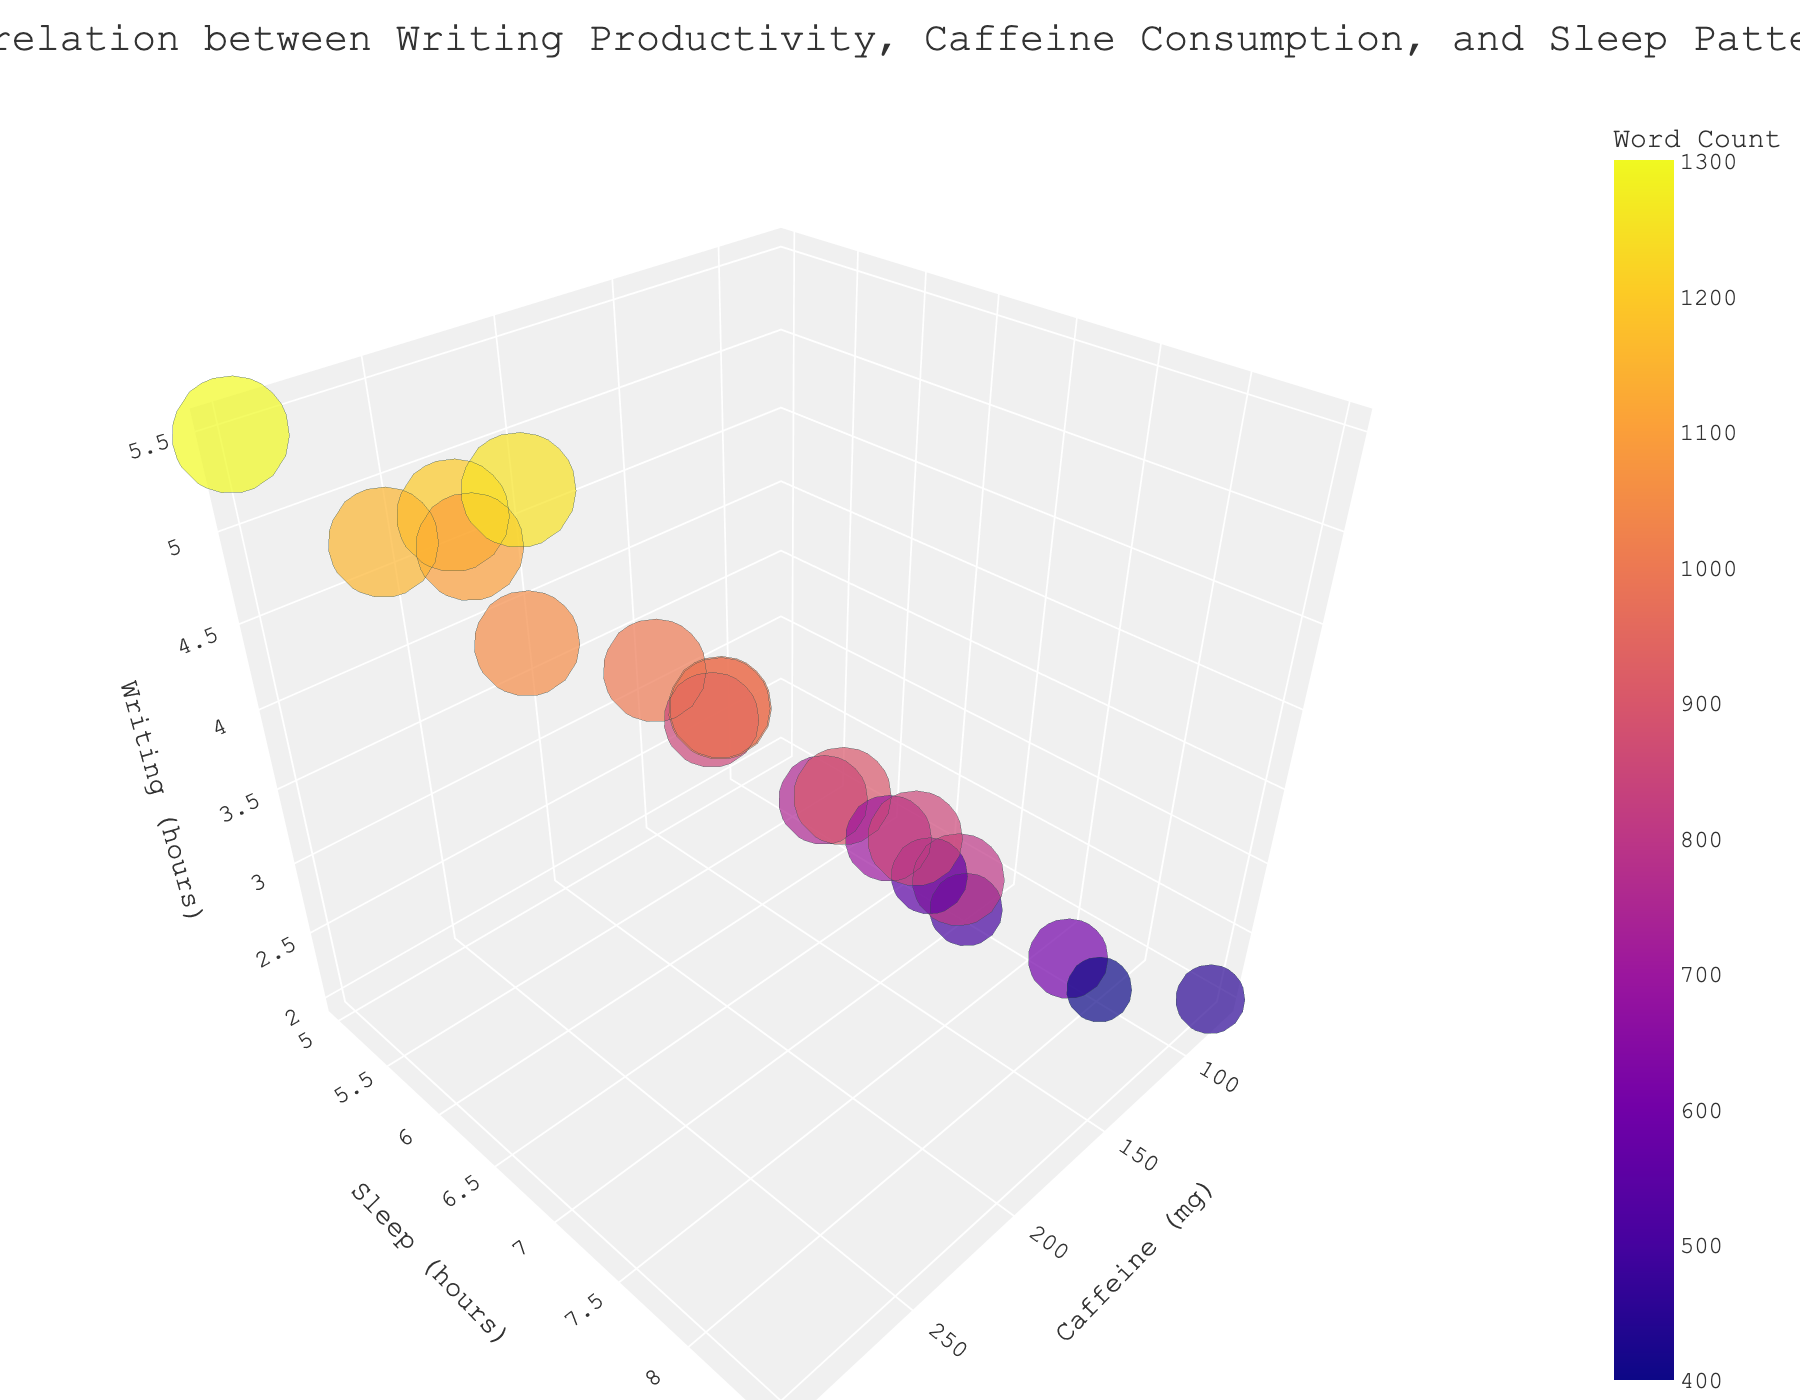What does the title of the chart indicate? The title "Correlation between Writing Productivity, Caffeine Consumption, and Sleep Patterns" suggests that the chart explores how writing hours (an indicator of productivity), caffeine intake, and sleep hours are related for aspiring authors.
Answer: It shows the relationship between writing hours, caffeine intake, and sleep What do the axes represent in the figure? The x-axis represents caffeine consumption in milligrams (Caffeine (mg)), the y-axis represents sleep duration in hours (Sleep (hours)), and the z-axis represents writing hours (Writing (hours)).
Answer: Caffeine intake, sleep duration, writing hours How many data points are shown in the figure? There are 20 data points visible on the chart, corresponding to 20 different observations in the dataset.
Answer: 20 Which data point has the highest word count? The data point located at approximately (300 mg, 5 hours, 5.5 hours) has the highest word count, indicated by the largest bubble in the chart.
Answer: 1300 How does increasing caffeine intake appear to affect writing hours? Generally, as caffeine intake increases, writing hours also appear to increase based on the upward trend observed along the z-axis.
Answer: Writing hours increase with caffeine What is the range of sleep hours shown in the figure? The values on the y-axis range from 5 hours to 8.5 hours of sleep.
Answer: 5 to 8.5 hours Which data points have the lowest word count, and what are their sleep patterns? The data points with the smallest bubbles, roughly located at (100 mg, 8 hours) and (75 mg, 8.5 hours), show the lowest word counts. These authors have relatively higher sleep durations.
Answer: 8 hours and 8.5 hours Which data point has the highest reported hours of sleep, and what is the corresponding word count? The data point at approximately (75 mg, 8.5 hours) of sleep shows the highest sleep hours, with a word count represented by one of the smallest bubbles.
Answer: 450 What is the relationship between word count and bubble size on the chart? Bubble size is directly proportional to word count; larger bubbles indicate higher word counts, while smaller bubbles indicate lower word counts.
Answer: Larger bubbles have higher word counts Is there any clear pattern between sleep hours and word count? The chart shows that lower sleep hours generally correspond to higher word counts, as the larger bubbles tend to be located at or below around 5.5 to 6.5 hours of sleep.
Answer: Lower sleep hours, higher word counts 